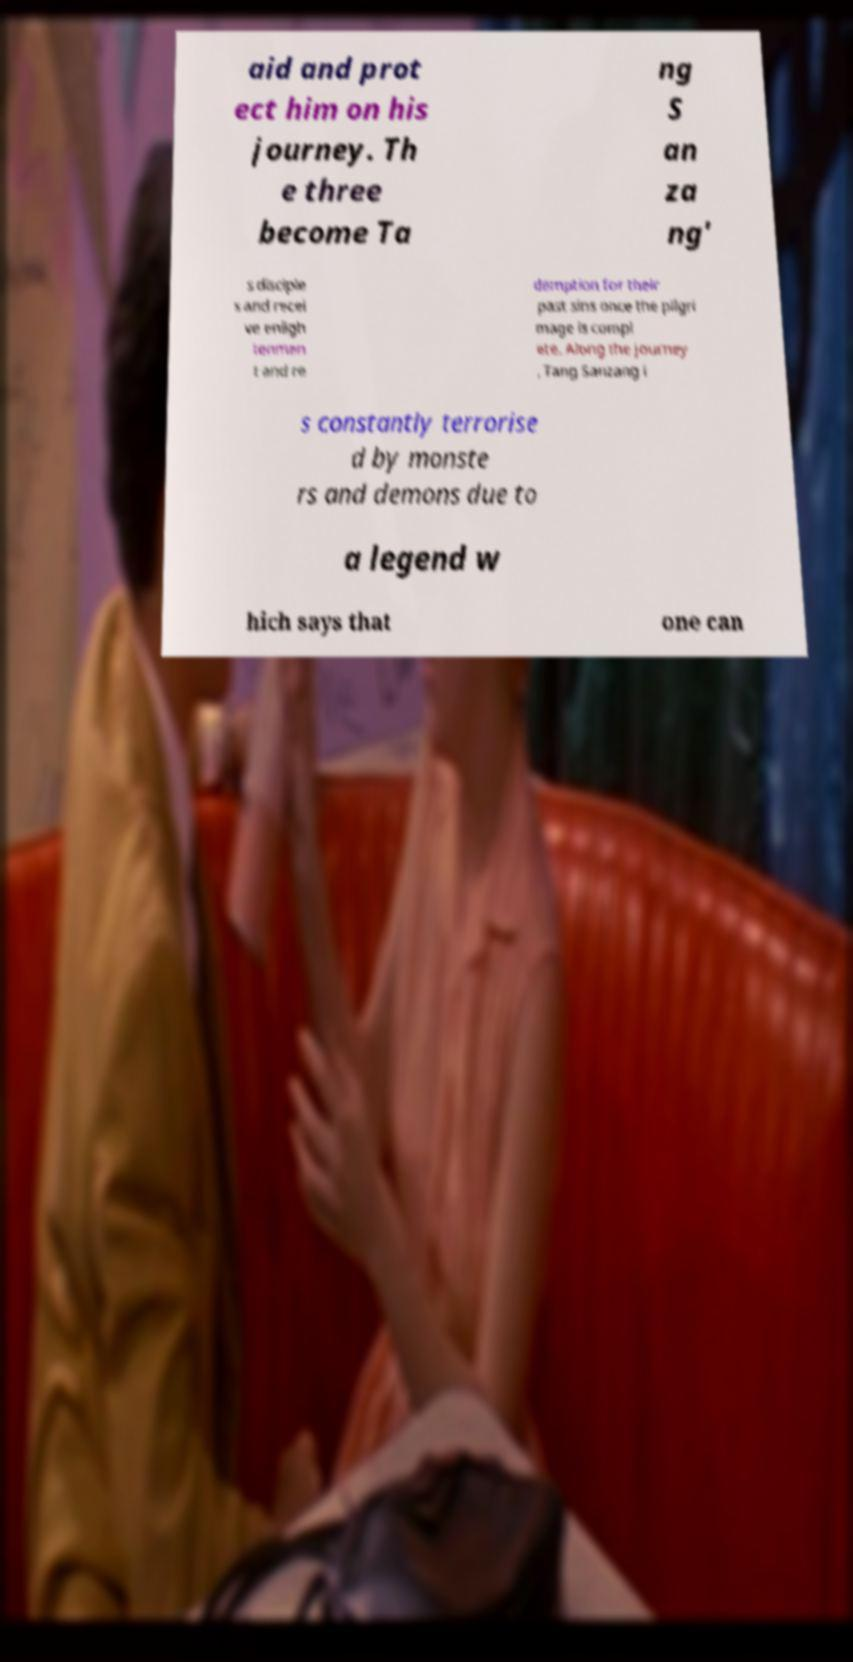Please read and relay the text visible in this image. What does it say? aid and prot ect him on his journey. Th e three become Ta ng S an za ng' s disciple s and recei ve enligh tenmen t and re demption for their past sins once the pilgri mage is compl ete. Along the journey , Tang Sanzang i s constantly terrorise d by monste rs and demons due to a legend w hich says that one can 